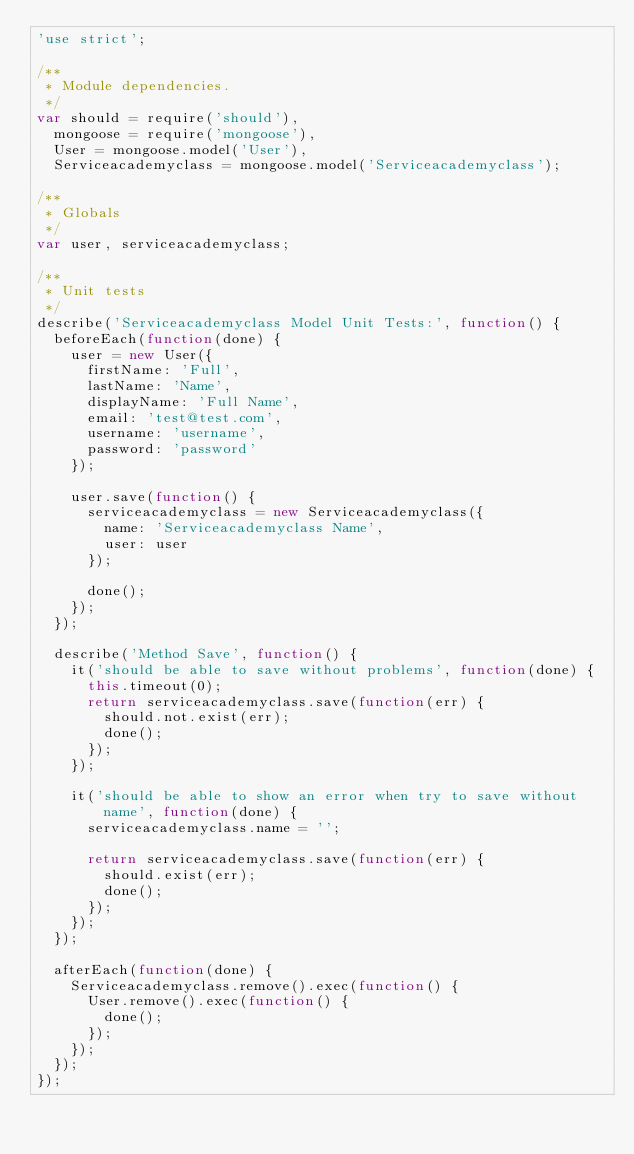Convert code to text. <code><loc_0><loc_0><loc_500><loc_500><_JavaScript_>'use strict';

/**
 * Module dependencies.
 */
var should = require('should'),
  mongoose = require('mongoose'),
  User = mongoose.model('User'),
  Serviceacademyclass = mongoose.model('Serviceacademyclass');

/**
 * Globals
 */
var user, serviceacademyclass;

/**
 * Unit tests
 */
describe('Serviceacademyclass Model Unit Tests:', function() {
  beforeEach(function(done) {
    user = new User({
      firstName: 'Full',
      lastName: 'Name',
      displayName: 'Full Name',
      email: 'test@test.com',
      username: 'username',
      password: 'password'
    });

    user.save(function() {
      serviceacademyclass = new Serviceacademyclass({
        name: 'Serviceacademyclass Name',
        user: user
      });

      done();
    });
  });

  describe('Method Save', function() {
    it('should be able to save without problems', function(done) {
      this.timeout(0);
      return serviceacademyclass.save(function(err) {
        should.not.exist(err);
        done();
      });
    });

    it('should be able to show an error when try to save without name', function(done) {
      serviceacademyclass.name = '';

      return serviceacademyclass.save(function(err) {
        should.exist(err);
        done();
      });
    });
  });

  afterEach(function(done) {
    Serviceacademyclass.remove().exec(function() {
      User.remove().exec(function() {
        done();
      });
    });
  });
});</code> 